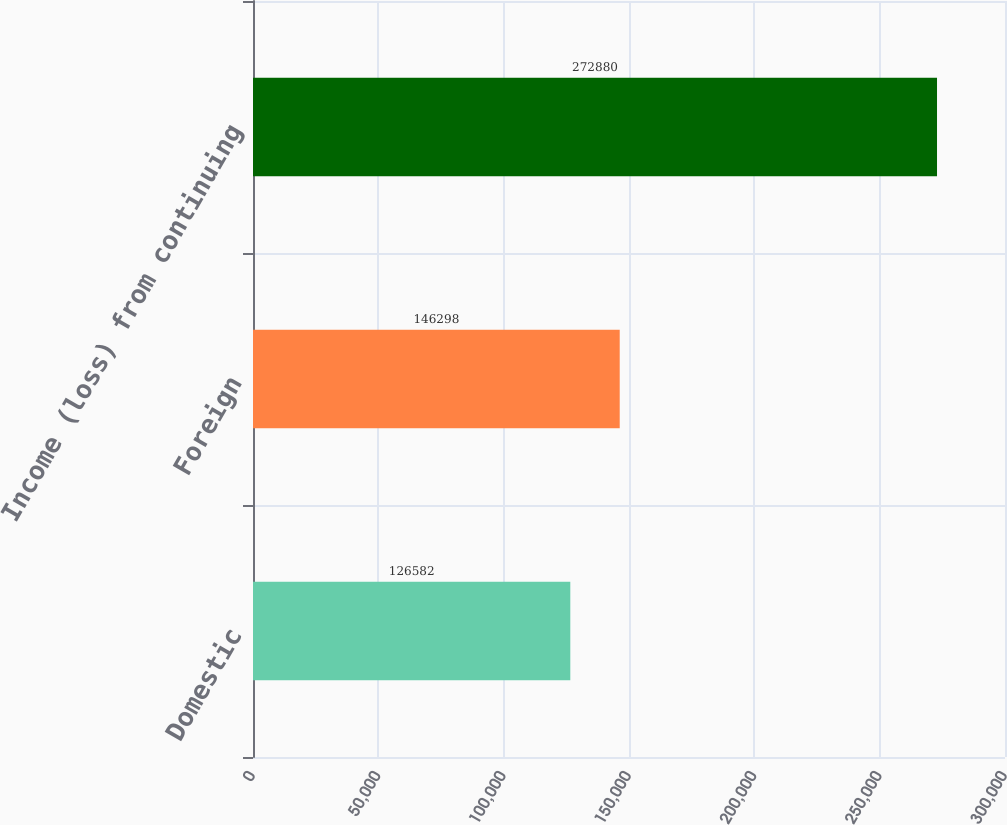Convert chart to OTSL. <chart><loc_0><loc_0><loc_500><loc_500><bar_chart><fcel>Domestic<fcel>Foreign<fcel>Income (loss) from continuing<nl><fcel>126582<fcel>146298<fcel>272880<nl></chart> 